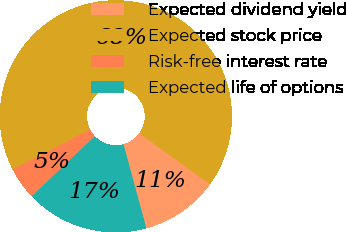Convert chart to OTSL. <chart><loc_0><loc_0><loc_500><loc_500><pie_chart><fcel>Expected dividend yield<fcel>Expected stock price<fcel>Risk-free interest rate<fcel>Expected life of options<nl><fcel>10.83%<fcel>67.52%<fcel>4.53%<fcel>17.12%<nl></chart> 